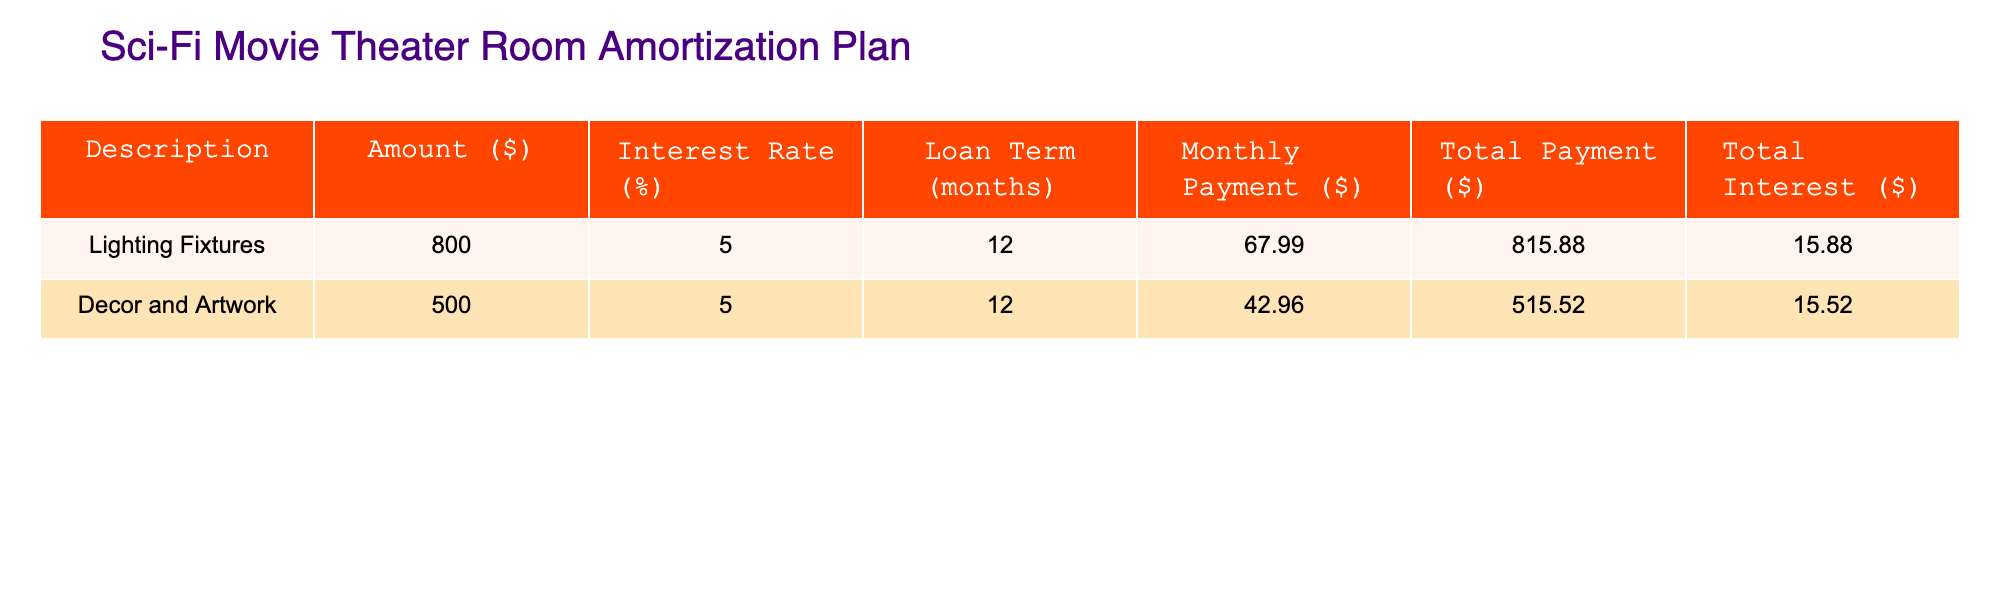What is the total payment for the Lighting Fixtures? The table shows that the total payment amount for Lighting Fixtures is listed directly under the "Total Payment ($)" column, which is 815.88.
Answer: 815.88 What is the monthly payment for Decor and Artwork? The monthly payment for Decor and Artwork is directly provided in the table under the "Monthly Payment ($)" column, which is 42.96.
Answer: 42.96 Is the total interest for Lighting Fixtures greater than that for Decor and Artwork? By comparing the "Total Interest ($)" column, the total interest for Lighting Fixtures is 15.88 and for Decor and Artwork is 15.52. Since 15.88 > 15.52, the statement is true.
Answer: Yes What is the combined total payment for both items? First, find the total payments for both items: 815.88 (Lighting Fixtures) + 515.52 (Decor and Artwork) = 1331.40. This is the total payment for both.
Answer: 1331.40 What is the difference in total interest between the two items? Calculate the difference by subtracting the total interest of Decor and Artwork from that of Lighting Fixtures: 15.88 - 15.52 = 0.36. This shows how much more interest is paid for Lighting Fixtures compared to Decor.
Answer: 0.36 What is the average monthly payment of the two items? To find the average, sum the monthly payments: 67.99 (Lighting Fixtures) + 42.96 (Decor and Artwork) = 110.95, then divide by the number of items (2): 110.95 / 2 = 55.48.
Answer: 55.48 Is the interest rate the same for both items? The table shows that both items have an interest rate of 5%, making this statement true.
Answer: Yes What is the maximum monthly payment among the two items? Compare the monthly payments: 67.99 (Lighting Fixtures) and 42.96 (Decor and Artwork). The maximum value is 67.99.
Answer: 67.99 What is the total amount paid for interest across both items? Sum the total interests for both items: 15.88 (Lighting Fixtures) + 15.52 (Decor and Artwork) = 31.40. This represents the total interest paid.
Answer: 31.40 